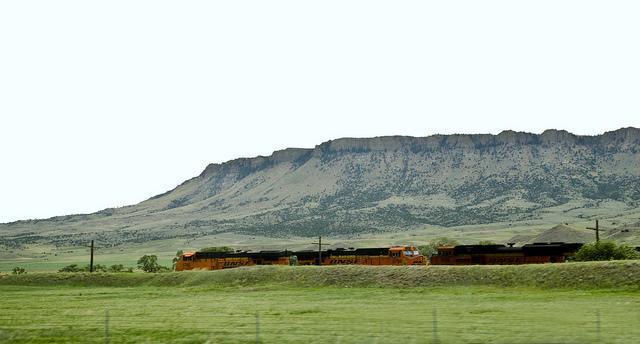How many trains are in the photo?
Give a very brief answer. 2. 